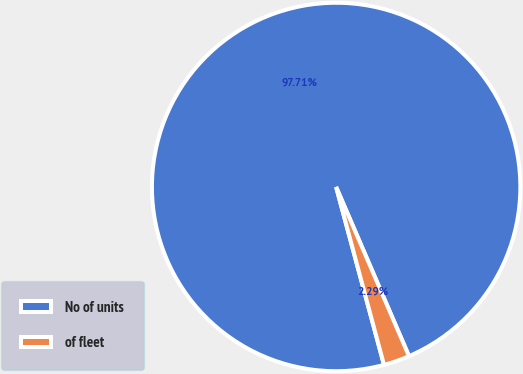<chart> <loc_0><loc_0><loc_500><loc_500><pie_chart><fcel>No of units<fcel>of fleet<nl><fcel>97.71%<fcel>2.29%<nl></chart> 